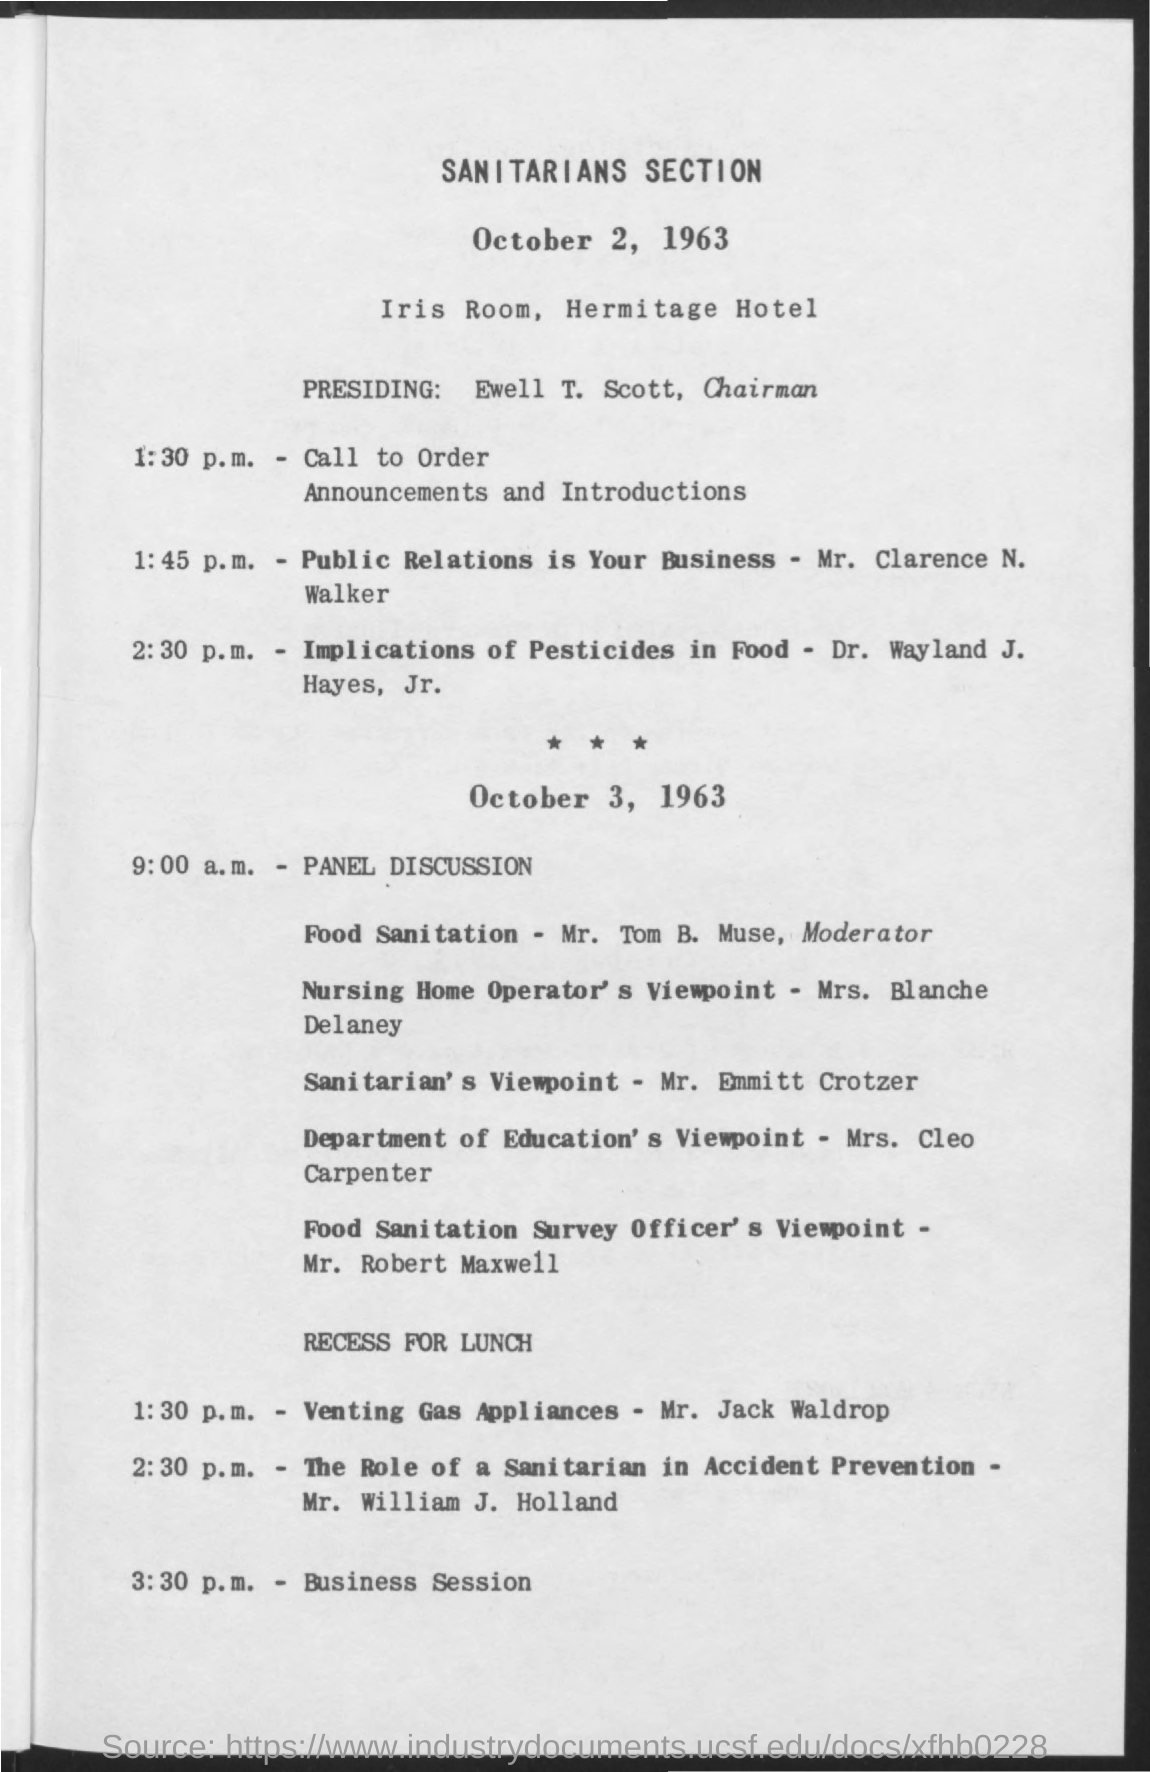Is there a specific theme for the discussions listed for October 3, 1963? Yes, the discussions on October 3, 1963, appear to focus on various viewpoints about sanitation and public health, including presentations from a nursing home operator, a sanitarian, and an education department, as well as a panel discussion on food sanitation and a session on the role of a sanitarian in accident prevention. 